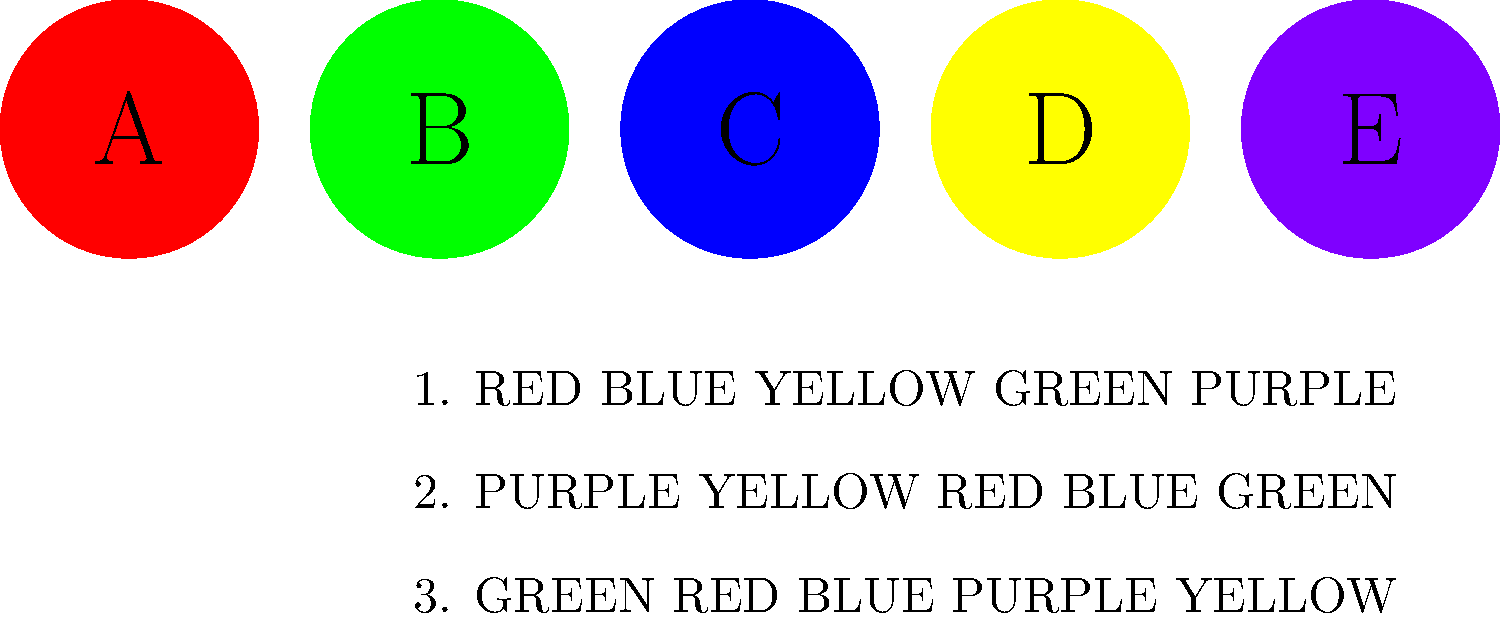A suspect has left a coded message at a crime scene. The message reads "CABDE". Using the visual cipher provided, what is the decoded message? To decode the message, we need to follow these steps:

1. Observe the visual cipher:
   - Each letter (A, B, C, D, E) corresponds to a colored circle.
   - A = Red, B = Green, C = Blue, D = Yellow, E = Purple

2. Analyze the given coded message: "CABDE"

3. Decode each letter:
   - C (Blue) = RED
   - A (Red) = BLUE
   - B (Green) = YELLOW
   - D (Yellow) = GREEN
   - E (Purple) = PURPLE

4. Combine the decoded colors:
   RED BLUE YELLOW GREEN PURPLE

5. Match the decoded sequence with the provided options:
   - Option 1 matches our decoded sequence exactly

Therefore, the decoded message corresponds to the first option in the visual cipher.
Answer: 1 